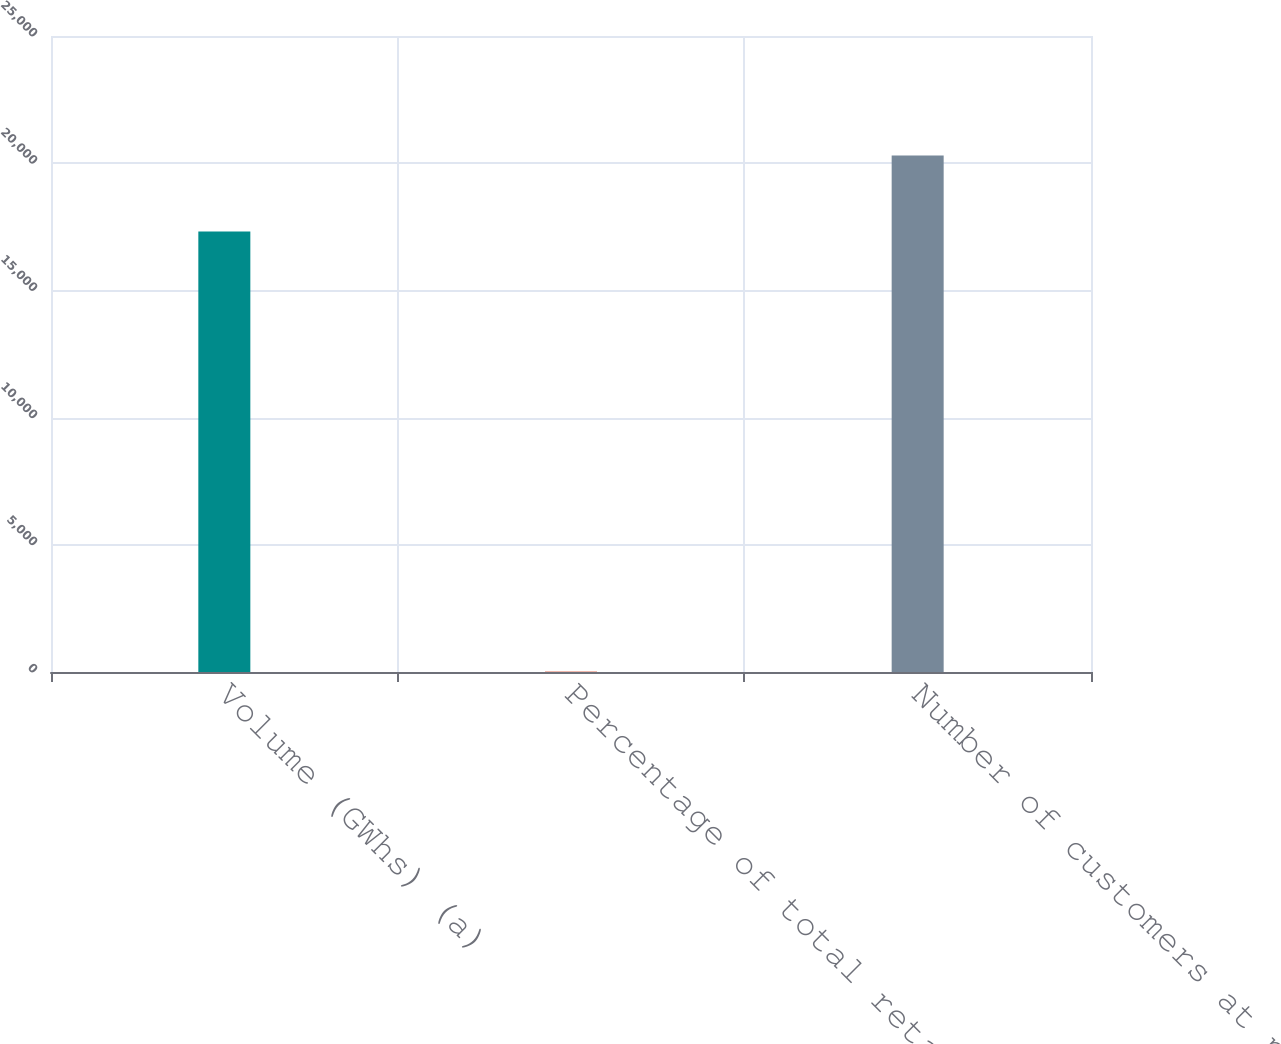<chart> <loc_0><loc_0><loc_500><loc_500><bar_chart><fcel>Volume (GWhs) (a)<fcel>Percentage of total retail<fcel>Number of customers at period<nl><fcel>17317<fcel>20<fcel>20300<nl></chart> 